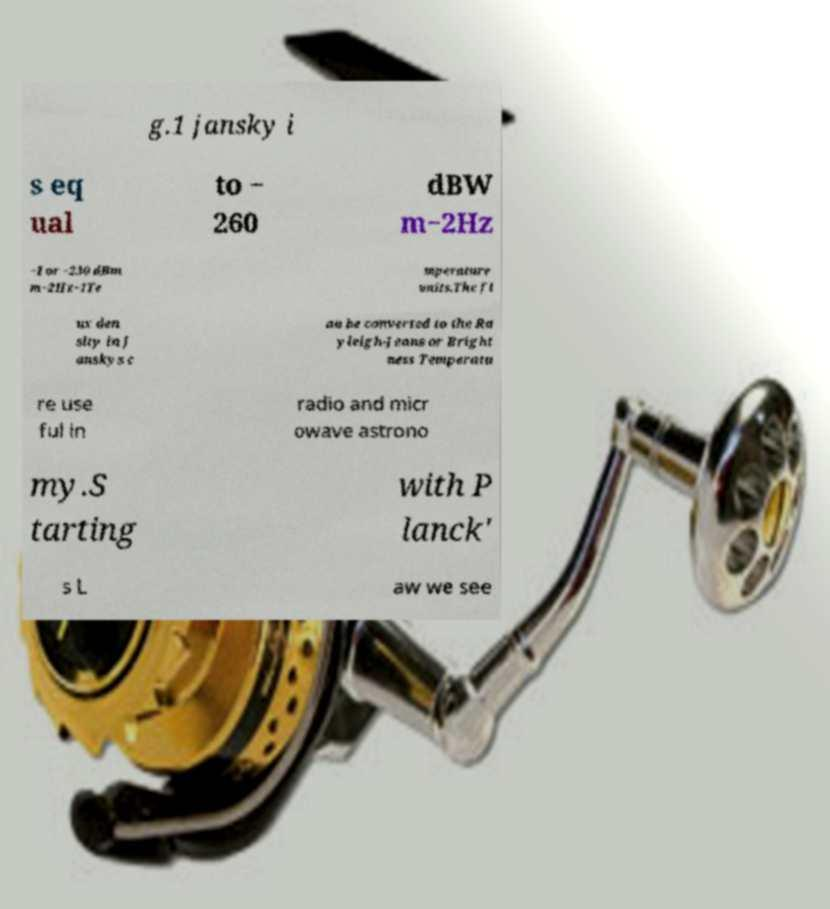Please read and relay the text visible in this image. What does it say? g.1 jansky i s eq ual to − 260 dBW m−2Hz −1 or −230 dBm m−2Hz−1Te mperature units.The fl ux den sity in J anskys c an be converted to the Ra yleigh-Jeans or Bright ness Temperatu re use ful in radio and micr owave astrono my.S tarting with P lanck' s L aw we see 